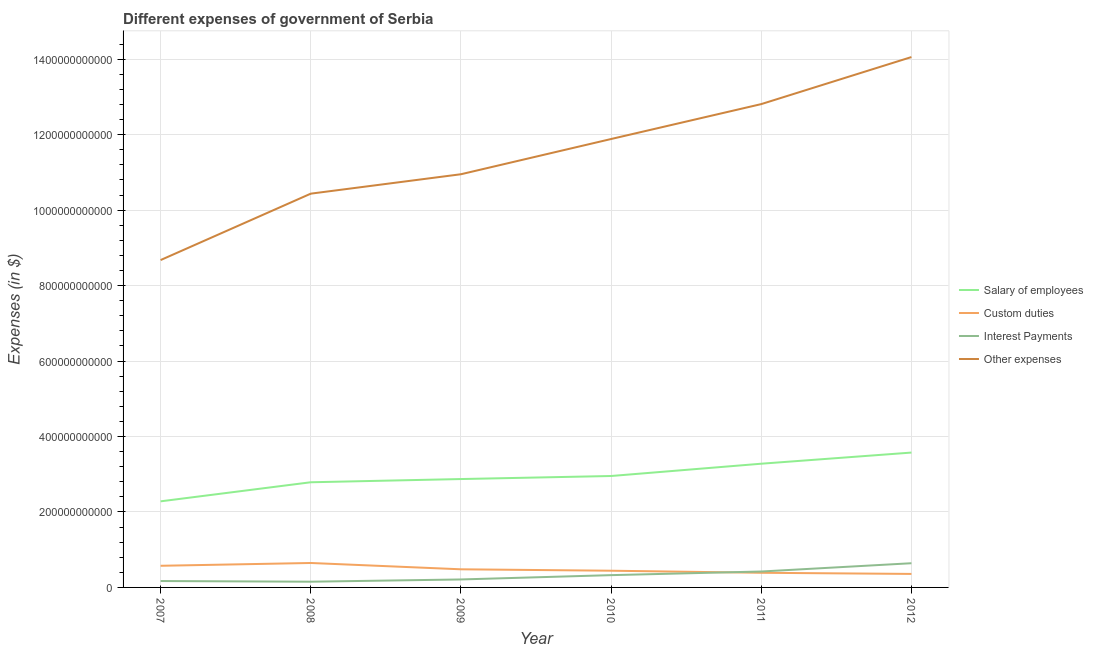What is the amount spent on other expenses in 2010?
Your answer should be compact. 1.19e+12. Across all years, what is the maximum amount spent on interest payments?
Give a very brief answer. 6.41e+1. Across all years, what is the minimum amount spent on interest payments?
Your response must be concise. 1.52e+1. In which year was the amount spent on interest payments maximum?
Your response must be concise. 2012. What is the total amount spent on salary of employees in the graph?
Make the answer very short. 1.77e+12. What is the difference between the amount spent on custom duties in 2008 and that in 2010?
Ensure brevity in your answer.  2.05e+1. What is the difference between the amount spent on interest payments in 2007 and the amount spent on custom duties in 2010?
Provide a succinct answer. -2.73e+1. What is the average amount spent on interest payments per year?
Your response must be concise. 3.20e+1. In the year 2012, what is the difference between the amount spent on custom duties and amount spent on salary of employees?
Your response must be concise. -3.22e+11. What is the ratio of the amount spent on other expenses in 2011 to that in 2012?
Offer a terse response. 0.91. Is the difference between the amount spent on salary of employees in 2007 and 2008 greater than the difference between the amount spent on custom duties in 2007 and 2008?
Your answer should be very brief. No. What is the difference between the highest and the second highest amount spent on custom duties?
Your response must be concise. 7.40e+09. What is the difference between the highest and the lowest amount spent on interest payments?
Your response must be concise. 4.89e+1. In how many years, is the amount spent on custom duties greater than the average amount spent on custom duties taken over all years?
Provide a short and direct response. 2. Is it the case that in every year, the sum of the amount spent on salary of employees and amount spent on custom duties is greater than the sum of amount spent on interest payments and amount spent on other expenses?
Keep it short and to the point. Yes. Is it the case that in every year, the sum of the amount spent on salary of employees and amount spent on custom duties is greater than the amount spent on interest payments?
Provide a succinct answer. Yes. Is the amount spent on interest payments strictly greater than the amount spent on other expenses over the years?
Make the answer very short. No. How many years are there in the graph?
Your answer should be very brief. 6. What is the difference between two consecutive major ticks on the Y-axis?
Ensure brevity in your answer.  2.00e+11. Does the graph contain any zero values?
Provide a short and direct response. No. Where does the legend appear in the graph?
Offer a terse response. Center right. How are the legend labels stacked?
Make the answer very short. Vertical. What is the title of the graph?
Provide a succinct answer. Different expenses of government of Serbia. Does "Taxes on goods and services" appear as one of the legend labels in the graph?
Keep it short and to the point. No. What is the label or title of the X-axis?
Give a very brief answer. Year. What is the label or title of the Y-axis?
Offer a terse response. Expenses (in $). What is the Expenses (in $) of Salary of employees in 2007?
Your answer should be very brief. 2.28e+11. What is the Expenses (in $) in Custom duties in 2007?
Your answer should be very brief. 5.74e+1. What is the Expenses (in $) of Interest Payments in 2007?
Provide a succinct answer. 1.70e+1. What is the Expenses (in $) in Other expenses in 2007?
Give a very brief answer. 8.68e+11. What is the Expenses (in $) in Salary of employees in 2008?
Keep it short and to the point. 2.79e+11. What is the Expenses (in $) in Custom duties in 2008?
Offer a terse response. 6.48e+1. What is the Expenses (in $) in Interest Payments in 2008?
Give a very brief answer. 1.52e+1. What is the Expenses (in $) of Other expenses in 2008?
Provide a short and direct response. 1.04e+12. What is the Expenses (in $) in Salary of employees in 2009?
Offer a terse response. 2.87e+11. What is the Expenses (in $) of Custom duties in 2009?
Your response must be concise. 4.80e+1. What is the Expenses (in $) of Interest Payments in 2009?
Keep it short and to the point. 2.11e+1. What is the Expenses (in $) of Other expenses in 2009?
Your response must be concise. 1.10e+12. What is the Expenses (in $) of Salary of employees in 2010?
Your answer should be compact. 2.95e+11. What is the Expenses (in $) of Custom duties in 2010?
Your answer should be very brief. 4.43e+1. What is the Expenses (in $) in Interest Payments in 2010?
Give a very brief answer. 3.26e+1. What is the Expenses (in $) of Other expenses in 2010?
Provide a short and direct response. 1.19e+12. What is the Expenses (in $) of Salary of employees in 2011?
Provide a succinct answer. 3.28e+11. What is the Expenses (in $) of Custom duties in 2011?
Provide a short and direct response. 3.88e+1. What is the Expenses (in $) of Interest Payments in 2011?
Offer a very short reply. 4.22e+1. What is the Expenses (in $) in Other expenses in 2011?
Offer a very short reply. 1.28e+12. What is the Expenses (in $) of Salary of employees in 2012?
Your response must be concise. 3.57e+11. What is the Expenses (in $) of Custom duties in 2012?
Your answer should be very brief. 3.58e+1. What is the Expenses (in $) of Interest Payments in 2012?
Give a very brief answer. 6.41e+1. What is the Expenses (in $) of Other expenses in 2012?
Your answer should be very brief. 1.41e+12. Across all years, what is the maximum Expenses (in $) in Salary of employees?
Provide a succinct answer. 3.57e+11. Across all years, what is the maximum Expenses (in $) in Custom duties?
Your answer should be very brief. 6.48e+1. Across all years, what is the maximum Expenses (in $) in Interest Payments?
Ensure brevity in your answer.  6.41e+1. Across all years, what is the maximum Expenses (in $) in Other expenses?
Make the answer very short. 1.41e+12. Across all years, what is the minimum Expenses (in $) in Salary of employees?
Offer a terse response. 2.28e+11. Across all years, what is the minimum Expenses (in $) in Custom duties?
Offer a very short reply. 3.58e+1. Across all years, what is the minimum Expenses (in $) in Interest Payments?
Your response must be concise. 1.52e+1. Across all years, what is the minimum Expenses (in $) in Other expenses?
Offer a terse response. 8.68e+11. What is the total Expenses (in $) of Salary of employees in the graph?
Provide a short and direct response. 1.77e+12. What is the total Expenses (in $) of Custom duties in the graph?
Keep it short and to the point. 2.89e+11. What is the total Expenses (in $) of Interest Payments in the graph?
Offer a very short reply. 1.92e+11. What is the total Expenses (in $) in Other expenses in the graph?
Give a very brief answer. 6.88e+12. What is the difference between the Expenses (in $) of Salary of employees in 2007 and that in 2008?
Offer a very short reply. -5.06e+1. What is the difference between the Expenses (in $) of Custom duties in 2007 and that in 2008?
Give a very brief answer. -7.40e+09. What is the difference between the Expenses (in $) in Interest Payments in 2007 and that in 2008?
Give a very brief answer. 1.78e+09. What is the difference between the Expenses (in $) in Other expenses in 2007 and that in 2008?
Your response must be concise. -1.76e+11. What is the difference between the Expenses (in $) in Salary of employees in 2007 and that in 2009?
Your response must be concise. -5.91e+1. What is the difference between the Expenses (in $) of Custom duties in 2007 and that in 2009?
Provide a succinct answer. 9.34e+09. What is the difference between the Expenses (in $) in Interest Payments in 2007 and that in 2009?
Provide a succinct answer. -4.17e+09. What is the difference between the Expenses (in $) in Other expenses in 2007 and that in 2009?
Offer a terse response. -2.27e+11. What is the difference between the Expenses (in $) of Salary of employees in 2007 and that in 2010?
Give a very brief answer. -6.72e+1. What is the difference between the Expenses (in $) in Custom duties in 2007 and that in 2010?
Make the answer very short. 1.31e+1. What is the difference between the Expenses (in $) in Interest Payments in 2007 and that in 2010?
Offer a very short reply. -1.56e+1. What is the difference between the Expenses (in $) in Other expenses in 2007 and that in 2010?
Ensure brevity in your answer.  -3.21e+11. What is the difference between the Expenses (in $) in Salary of employees in 2007 and that in 2011?
Your answer should be very brief. -9.97e+1. What is the difference between the Expenses (in $) of Custom duties in 2007 and that in 2011?
Provide a succinct answer. 1.86e+1. What is the difference between the Expenses (in $) of Interest Payments in 2007 and that in 2011?
Provide a succinct answer. -2.52e+1. What is the difference between the Expenses (in $) in Other expenses in 2007 and that in 2011?
Offer a terse response. -4.13e+11. What is the difference between the Expenses (in $) of Salary of employees in 2007 and that in 2012?
Ensure brevity in your answer.  -1.29e+11. What is the difference between the Expenses (in $) of Custom duties in 2007 and that in 2012?
Give a very brief answer. 2.16e+1. What is the difference between the Expenses (in $) of Interest Payments in 2007 and that in 2012?
Your answer should be very brief. -4.72e+1. What is the difference between the Expenses (in $) in Other expenses in 2007 and that in 2012?
Offer a very short reply. -5.38e+11. What is the difference between the Expenses (in $) of Salary of employees in 2008 and that in 2009?
Keep it short and to the point. -8.54e+09. What is the difference between the Expenses (in $) of Custom duties in 2008 and that in 2009?
Provide a short and direct response. 1.67e+1. What is the difference between the Expenses (in $) in Interest Payments in 2008 and that in 2009?
Offer a terse response. -5.95e+09. What is the difference between the Expenses (in $) in Other expenses in 2008 and that in 2009?
Your response must be concise. -5.15e+1. What is the difference between the Expenses (in $) in Salary of employees in 2008 and that in 2010?
Provide a short and direct response. -1.66e+1. What is the difference between the Expenses (in $) in Custom duties in 2008 and that in 2010?
Make the answer very short. 2.05e+1. What is the difference between the Expenses (in $) of Interest Payments in 2008 and that in 2010?
Offer a very short reply. -1.74e+1. What is the difference between the Expenses (in $) in Other expenses in 2008 and that in 2010?
Offer a very short reply. -1.45e+11. What is the difference between the Expenses (in $) in Salary of employees in 2008 and that in 2011?
Offer a very short reply. -4.92e+1. What is the difference between the Expenses (in $) in Custom duties in 2008 and that in 2011?
Offer a very short reply. 2.60e+1. What is the difference between the Expenses (in $) in Interest Payments in 2008 and that in 2011?
Provide a succinct answer. -2.70e+1. What is the difference between the Expenses (in $) of Other expenses in 2008 and that in 2011?
Provide a short and direct response. -2.37e+11. What is the difference between the Expenses (in $) in Salary of employees in 2008 and that in 2012?
Keep it short and to the point. -7.87e+1. What is the difference between the Expenses (in $) in Custom duties in 2008 and that in 2012?
Your answer should be very brief. 2.90e+1. What is the difference between the Expenses (in $) of Interest Payments in 2008 and that in 2012?
Keep it short and to the point. -4.89e+1. What is the difference between the Expenses (in $) of Other expenses in 2008 and that in 2012?
Your answer should be compact. -3.62e+11. What is the difference between the Expenses (in $) of Salary of employees in 2009 and that in 2010?
Ensure brevity in your answer.  -8.06e+09. What is the difference between the Expenses (in $) in Custom duties in 2009 and that in 2010?
Make the answer very short. 3.75e+09. What is the difference between the Expenses (in $) of Interest Payments in 2009 and that in 2010?
Make the answer very short. -1.14e+1. What is the difference between the Expenses (in $) of Other expenses in 2009 and that in 2010?
Ensure brevity in your answer.  -9.34e+1. What is the difference between the Expenses (in $) of Salary of employees in 2009 and that in 2011?
Give a very brief answer. -4.06e+1. What is the difference between the Expenses (in $) of Custom duties in 2009 and that in 2011?
Your answer should be very brief. 9.24e+09. What is the difference between the Expenses (in $) in Interest Payments in 2009 and that in 2011?
Make the answer very short. -2.11e+1. What is the difference between the Expenses (in $) in Other expenses in 2009 and that in 2011?
Make the answer very short. -1.86e+11. What is the difference between the Expenses (in $) in Salary of employees in 2009 and that in 2012?
Offer a very short reply. -7.02e+1. What is the difference between the Expenses (in $) in Custom duties in 2009 and that in 2012?
Your answer should be very brief. 1.23e+1. What is the difference between the Expenses (in $) of Interest Payments in 2009 and that in 2012?
Offer a very short reply. -4.30e+1. What is the difference between the Expenses (in $) in Other expenses in 2009 and that in 2012?
Make the answer very short. -3.11e+11. What is the difference between the Expenses (in $) of Salary of employees in 2010 and that in 2011?
Your response must be concise. -3.26e+1. What is the difference between the Expenses (in $) of Custom duties in 2010 and that in 2011?
Your answer should be very brief. 5.48e+09. What is the difference between the Expenses (in $) in Interest Payments in 2010 and that in 2011?
Your answer should be very brief. -9.63e+09. What is the difference between the Expenses (in $) in Other expenses in 2010 and that in 2011?
Your answer should be very brief. -9.25e+1. What is the difference between the Expenses (in $) in Salary of employees in 2010 and that in 2012?
Make the answer very short. -6.21e+1. What is the difference between the Expenses (in $) in Custom duties in 2010 and that in 2012?
Ensure brevity in your answer.  8.50e+09. What is the difference between the Expenses (in $) of Interest Payments in 2010 and that in 2012?
Your answer should be very brief. -3.16e+1. What is the difference between the Expenses (in $) of Other expenses in 2010 and that in 2012?
Ensure brevity in your answer.  -2.17e+11. What is the difference between the Expenses (in $) of Salary of employees in 2011 and that in 2012?
Your response must be concise. -2.95e+1. What is the difference between the Expenses (in $) of Custom duties in 2011 and that in 2012?
Offer a very short reply. 3.02e+09. What is the difference between the Expenses (in $) in Interest Payments in 2011 and that in 2012?
Make the answer very short. -2.19e+1. What is the difference between the Expenses (in $) of Other expenses in 2011 and that in 2012?
Provide a short and direct response. -1.25e+11. What is the difference between the Expenses (in $) of Salary of employees in 2007 and the Expenses (in $) of Custom duties in 2008?
Make the answer very short. 1.63e+11. What is the difference between the Expenses (in $) of Salary of employees in 2007 and the Expenses (in $) of Interest Payments in 2008?
Offer a very short reply. 2.13e+11. What is the difference between the Expenses (in $) in Salary of employees in 2007 and the Expenses (in $) in Other expenses in 2008?
Your answer should be compact. -8.15e+11. What is the difference between the Expenses (in $) in Custom duties in 2007 and the Expenses (in $) in Interest Payments in 2008?
Provide a succinct answer. 4.22e+1. What is the difference between the Expenses (in $) of Custom duties in 2007 and the Expenses (in $) of Other expenses in 2008?
Ensure brevity in your answer.  -9.86e+11. What is the difference between the Expenses (in $) in Interest Payments in 2007 and the Expenses (in $) in Other expenses in 2008?
Provide a short and direct response. -1.03e+12. What is the difference between the Expenses (in $) in Salary of employees in 2007 and the Expenses (in $) in Custom duties in 2009?
Your response must be concise. 1.80e+11. What is the difference between the Expenses (in $) of Salary of employees in 2007 and the Expenses (in $) of Interest Payments in 2009?
Your response must be concise. 2.07e+11. What is the difference between the Expenses (in $) in Salary of employees in 2007 and the Expenses (in $) in Other expenses in 2009?
Give a very brief answer. -8.67e+11. What is the difference between the Expenses (in $) of Custom duties in 2007 and the Expenses (in $) of Interest Payments in 2009?
Keep it short and to the point. 3.62e+1. What is the difference between the Expenses (in $) of Custom duties in 2007 and the Expenses (in $) of Other expenses in 2009?
Ensure brevity in your answer.  -1.04e+12. What is the difference between the Expenses (in $) in Interest Payments in 2007 and the Expenses (in $) in Other expenses in 2009?
Make the answer very short. -1.08e+12. What is the difference between the Expenses (in $) in Salary of employees in 2007 and the Expenses (in $) in Custom duties in 2010?
Your answer should be very brief. 1.84e+11. What is the difference between the Expenses (in $) in Salary of employees in 2007 and the Expenses (in $) in Interest Payments in 2010?
Provide a succinct answer. 1.96e+11. What is the difference between the Expenses (in $) of Salary of employees in 2007 and the Expenses (in $) of Other expenses in 2010?
Give a very brief answer. -9.60e+11. What is the difference between the Expenses (in $) of Custom duties in 2007 and the Expenses (in $) of Interest Payments in 2010?
Provide a short and direct response. 2.48e+1. What is the difference between the Expenses (in $) of Custom duties in 2007 and the Expenses (in $) of Other expenses in 2010?
Your answer should be very brief. -1.13e+12. What is the difference between the Expenses (in $) in Interest Payments in 2007 and the Expenses (in $) in Other expenses in 2010?
Ensure brevity in your answer.  -1.17e+12. What is the difference between the Expenses (in $) in Salary of employees in 2007 and the Expenses (in $) in Custom duties in 2011?
Offer a terse response. 1.89e+11. What is the difference between the Expenses (in $) of Salary of employees in 2007 and the Expenses (in $) of Interest Payments in 2011?
Your answer should be very brief. 1.86e+11. What is the difference between the Expenses (in $) in Salary of employees in 2007 and the Expenses (in $) in Other expenses in 2011?
Offer a very short reply. -1.05e+12. What is the difference between the Expenses (in $) in Custom duties in 2007 and the Expenses (in $) in Interest Payments in 2011?
Ensure brevity in your answer.  1.52e+1. What is the difference between the Expenses (in $) of Custom duties in 2007 and the Expenses (in $) of Other expenses in 2011?
Offer a terse response. -1.22e+12. What is the difference between the Expenses (in $) of Interest Payments in 2007 and the Expenses (in $) of Other expenses in 2011?
Make the answer very short. -1.26e+12. What is the difference between the Expenses (in $) of Salary of employees in 2007 and the Expenses (in $) of Custom duties in 2012?
Your response must be concise. 1.92e+11. What is the difference between the Expenses (in $) in Salary of employees in 2007 and the Expenses (in $) in Interest Payments in 2012?
Provide a short and direct response. 1.64e+11. What is the difference between the Expenses (in $) of Salary of employees in 2007 and the Expenses (in $) of Other expenses in 2012?
Offer a terse response. -1.18e+12. What is the difference between the Expenses (in $) in Custom duties in 2007 and the Expenses (in $) in Interest Payments in 2012?
Keep it short and to the point. -6.75e+09. What is the difference between the Expenses (in $) of Custom duties in 2007 and the Expenses (in $) of Other expenses in 2012?
Your answer should be compact. -1.35e+12. What is the difference between the Expenses (in $) of Interest Payments in 2007 and the Expenses (in $) of Other expenses in 2012?
Your answer should be very brief. -1.39e+12. What is the difference between the Expenses (in $) of Salary of employees in 2008 and the Expenses (in $) of Custom duties in 2009?
Ensure brevity in your answer.  2.31e+11. What is the difference between the Expenses (in $) of Salary of employees in 2008 and the Expenses (in $) of Interest Payments in 2009?
Your answer should be compact. 2.58e+11. What is the difference between the Expenses (in $) of Salary of employees in 2008 and the Expenses (in $) of Other expenses in 2009?
Give a very brief answer. -8.16e+11. What is the difference between the Expenses (in $) of Custom duties in 2008 and the Expenses (in $) of Interest Payments in 2009?
Offer a terse response. 4.37e+1. What is the difference between the Expenses (in $) in Custom duties in 2008 and the Expenses (in $) in Other expenses in 2009?
Your answer should be very brief. -1.03e+12. What is the difference between the Expenses (in $) in Interest Payments in 2008 and the Expenses (in $) in Other expenses in 2009?
Make the answer very short. -1.08e+12. What is the difference between the Expenses (in $) of Salary of employees in 2008 and the Expenses (in $) of Custom duties in 2010?
Keep it short and to the point. 2.34e+11. What is the difference between the Expenses (in $) of Salary of employees in 2008 and the Expenses (in $) of Interest Payments in 2010?
Provide a short and direct response. 2.46e+11. What is the difference between the Expenses (in $) of Salary of employees in 2008 and the Expenses (in $) of Other expenses in 2010?
Provide a succinct answer. -9.10e+11. What is the difference between the Expenses (in $) in Custom duties in 2008 and the Expenses (in $) in Interest Payments in 2010?
Provide a succinct answer. 3.22e+1. What is the difference between the Expenses (in $) in Custom duties in 2008 and the Expenses (in $) in Other expenses in 2010?
Your answer should be very brief. -1.12e+12. What is the difference between the Expenses (in $) of Interest Payments in 2008 and the Expenses (in $) of Other expenses in 2010?
Offer a terse response. -1.17e+12. What is the difference between the Expenses (in $) in Salary of employees in 2008 and the Expenses (in $) in Custom duties in 2011?
Give a very brief answer. 2.40e+11. What is the difference between the Expenses (in $) in Salary of employees in 2008 and the Expenses (in $) in Interest Payments in 2011?
Ensure brevity in your answer.  2.37e+11. What is the difference between the Expenses (in $) of Salary of employees in 2008 and the Expenses (in $) of Other expenses in 2011?
Your answer should be compact. -1.00e+12. What is the difference between the Expenses (in $) of Custom duties in 2008 and the Expenses (in $) of Interest Payments in 2011?
Offer a terse response. 2.26e+1. What is the difference between the Expenses (in $) of Custom duties in 2008 and the Expenses (in $) of Other expenses in 2011?
Ensure brevity in your answer.  -1.22e+12. What is the difference between the Expenses (in $) of Interest Payments in 2008 and the Expenses (in $) of Other expenses in 2011?
Provide a short and direct response. -1.27e+12. What is the difference between the Expenses (in $) of Salary of employees in 2008 and the Expenses (in $) of Custom duties in 2012?
Make the answer very short. 2.43e+11. What is the difference between the Expenses (in $) in Salary of employees in 2008 and the Expenses (in $) in Interest Payments in 2012?
Your answer should be very brief. 2.15e+11. What is the difference between the Expenses (in $) of Salary of employees in 2008 and the Expenses (in $) of Other expenses in 2012?
Give a very brief answer. -1.13e+12. What is the difference between the Expenses (in $) in Custom duties in 2008 and the Expenses (in $) in Interest Payments in 2012?
Give a very brief answer. 6.49e+08. What is the difference between the Expenses (in $) in Custom duties in 2008 and the Expenses (in $) in Other expenses in 2012?
Offer a terse response. -1.34e+12. What is the difference between the Expenses (in $) of Interest Payments in 2008 and the Expenses (in $) of Other expenses in 2012?
Give a very brief answer. -1.39e+12. What is the difference between the Expenses (in $) in Salary of employees in 2009 and the Expenses (in $) in Custom duties in 2010?
Your answer should be compact. 2.43e+11. What is the difference between the Expenses (in $) of Salary of employees in 2009 and the Expenses (in $) of Interest Payments in 2010?
Ensure brevity in your answer.  2.55e+11. What is the difference between the Expenses (in $) in Salary of employees in 2009 and the Expenses (in $) in Other expenses in 2010?
Give a very brief answer. -9.01e+11. What is the difference between the Expenses (in $) of Custom duties in 2009 and the Expenses (in $) of Interest Payments in 2010?
Your answer should be very brief. 1.55e+1. What is the difference between the Expenses (in $) of Custom duties in 2009 and the Expenses (in $) of Other expenses in 2010?
Provide a short and direct response. -1.14e+12. What is the difference between the Expenses (in $) of Interest Payments in 2009 and the Expenses (in $) of Other expenses in 2010?
Make the answer very short. -1.17e+12. What is the difference between the Expenses (in $) of Salary of employees in 2009 and the Expenses (in $) of Custom duties in 2011?
Your response must be concise. 2.48e+11. What is the difference between the Expenses (in $) of Salary of employees in 2009 and the Expenses (in $) of Interest Payments in 2011?
Give a very brief answer. 2.45e+11. What is the difference between the Expenses (in $) in Salary of employees in 2009 and the Expenses (in $) in Other expenses in 2011?
Make the answer very short. -9.94e+11. What is the difference between the Expenses (in $) of Custom duties in 2009 and the Expenses (in $) of Interest Payments in 2011?
Make the answer very short. 5.85e+09. What is the difference between the Expenses (in $) of Custom duties in 2009 and the Expenses (in $) of Other expenses in 2011?
Give a very brief answer. -1.23e+12. What is the difference between the Expenses (in $) in Interest Payments in 2009 and the Expenses (in $) in Other expenses in 2011?
Provide a short and direct response. -1.26e+12. What is the difference between the Expenses (in $) in Salary of employees in 2009 and the Expenses (in $) in Custom duties in 2012?
Make the answer very short. 2.51e+11. What is the difference between the Expenses (in $) of Salary of employees in 2009 and the Expenses (in $) of Interest Payments in 2012?
Offer a very short reply. 2.23e+11. What is the difference between the Expenses (in $) in Salary of employees in 2009 and the Expenses (in $) in Other expenses in 2012?
Provide a succinct answer. -1.12e+12. What is the difference between the Expenses (in $) in Custom duties in 2009 and the Expenses (in $) in Interest Payments in 2012?
Offer a very short reply. -1.61e+1. What is the difference between the Expenses (in $) of Custom duties in 2009 and the Expenses (in $) of Other expenses in 2012?
Provide a short and direct response. -1.36e+12. What is the difference between the Expenses (in $) of Interest Payments in 2009 and the Expenses (in $) of Other expenses in 2012?
Ensure brevity in your answer.  -1.38e+12. What is the difference between the Expenses (in $) in Salary of employees in 2010 and the Expenses (in $) in Custom duties in 2011?
Your answer should be very brief. 2.57e+11. What is the difference between the Expenses (in $) in Salary of employees in 2010 and the Expenses (in $) in Interest Payments in 2011?
Keep it short and to the point. 2.53e+11. What is the difference between the Expenses (in $) in Salary of employees in 2010 and the Expenses (in $) in Other expenses in 2011?
Ensure brevity in your answer.  -9.86e+11. What is the difference between the Expenses (in $) in Custom duties in 2010 and the Expenses (in $) in Interest Payments in 2011?
Give a very brief answer. 2.09e+09. What is the difference between the Expenses (in $) of Custom duties in 2010 and the Expenses (in $) of Other expenses in 2011?
Offer a terse response. -1.24e+12. What is the difference between the Expenses (in $) of Interest Payments in 2010 and the Expenses (in $) of Other expenses in 2011?
Offer a very short reply. -1.25e+12. What is the difference between the Expenses (in $) in Salary of employees in 2010 and the Expenses (in $) in Custom duties in 2012?
Keep it short and to the point. 2.60e+11. What is the difference between the Expenses (in $) in Salary of employees in 2010 and the Expenses (in $) in Interest Payments in 2012?
Provide a short and direct response. 2.31e+11. What is the difference between the Expenses (in $) of Salary of employees in 2010 and the Expenses (in $) of Other expenses in 2012?
Your answer should be compact. -1.11e+12. What is the difference between the Expenses (in $) in Custom duties in 2010 and the Expenses (in $) in Interest Payments in 2012?
Your response must be concise. -1.98e+1. What is the difference between the Expenses (in $) in Custom duties in 2010 and the Expenses (in $) in Other expenses in 2012?
Offer a terse response. -1.36e+12. What is the difference between the Expenses (in $) of Interest Payments in 2010 and the Expenses (in $) of Other expenses in 2012?
Ensure brevity in your answer.  -1.37e+12. What is the difference between the Expenses (in $) in Salary of employees in 2011 and the Expenses (in $) in Custom duties in 2012?
Give a very brief answer. 2.92e+11. What is the difference between the Expenses (in $) in Salary of employees in 2011 and the Expenses (in $) in Interest Payments in 2012?
Keep it short and to the point. 2.64e+11. What is the difference between the Expenses (in $) of Salary of employees in 2011 and the Expenses (in $) of Other expenses in 2012?
Offer a very short reply. -1.08e+12. What is the difference between the Expenses (in $) in Custom duties in 2011 and the Expenses (in $) in Interest Payments in 2012?
Ensure brevity in your answer.  -2.53e+1. What is the difference between the Expenses (in $) in Custom duties in 2011 and the Expenses (in $) in Other expenses in 2012?
Provide a succinct answer. -1.37e+12. What is the difference between the Expenses (in $) of Interest Payments in 2011 and the Expenses (in $) of Other expenses in 2012?
Your answer should be very brief. -1.36e+12. What is the average Expenses (in $) in Salary of employees per year?
Keep it short and to the point. 2.96e+11. What is the average Expenses (in $) of Custom duties per year?
Keep it short and to the point. 4.82e+1. What is the average Expenses (in $) in Interest Payments per year?
Your answer should be very brief. 3.20e+1. What is the average Expenses (in $) of Other expenses per year?
Keep it short and to the point. 1.15e+12. In the year 2007, what is the difference between the Expenses (in $) of Salary of employees and Expenses (in $) of Custom duties?
Offer a terse response. 1.71e+11. In the year 2007, what is the difference between the Expenses (in $) in Salary of employees and Expenses (in $) in Interest Payments?
Make the answer very short. 2.11e+11. In the year 2007, what is the difference between the Expenses (in $) of Salary of employees and Expenses (in $) of Other expenses?
Ensure brevity in your answer.  -6.39e+11. In the year 2007, what is the difference between the Expenses (in $) of Custom duties and Expenses (in $) of Interest Payments?
Offer a very short reply. 4.04e+1. In the year 2007, what is the difference between the Expenses (in $) of Custom duties and Expenses (in $) of Other expenses?
Your answer should be compact. -8.10e+11. In the year 2007, what is the difference between the Expenses (in $) of Interest Payments and Expenses (in $) of Other expenses?
Make the answer very short. -8.51e+11. In the year 2008, what is the difference between the Expenses (in $) of Salary of employees and Expenses (in $) of Custom duties?
Offer a very short reply. 2.14e+11. In the year 2008, what is the difference between the Expenses (in $) of Salary of employees and Expenses (in $) of Interest Payments?
Keep it short and to the point. 2.64e+11. In the year 2008, what is the difference between the Expenses (in $) of Salary of employees and Expenses (in $) of Other expenses?
Keep it short and to the point. -7.65e+11. In the year 2008, what is the difference between the Expenses (in $) in Custom duties and Expenses (in $) in Interest Payments?
Your response must be concise. 4.96e+1. In the year 2008, what is the difference between the Expenses (in $) in Custom duties and Expenses (in $) in Other expenses?
Your answer should be compact. -9.79e+11. In the year 2008, what is the difference between the Expenses (in $) in Interest Payments and Expenses (in $) in Other expenses?
Offer a very short reply. -1.03e+12. In the year 2009, what is the difference between the Expenses (in $) of Salary of employees and Expenses (in $) of Custom duties?
Offer a terse response. 2.39e+11. In the year 2009, what is the difference between the Expenses (in $) in Salary of employees and Expenses (in $) in Interest Payments?
Provide a succinct answer. 2.66e+11. In the year 2009, what is the difference between the Expenses (in $) of Salary of employees and Expenses (in $) of Other expenses?
Keep it short and to the point. -8.08e+11. In the year 2009, what is the difference between the Expenses (in $) of Custom duties and Expenses (in $) of Interest Payments?
Give a very brief answer. 2.69e+1. In the year 2009, what is the difference between the Expenses (in $) of Custom duties and Expenses (in $) of Other expenses?
Keep it short and to the point. -1.05e+12. In the year 2009, what is the difference between the Expenses (in $) in Interest Payments and Expenses (in $) in Other expenses?
Give a very brief answer. -1.07e+12. In the year 2010, what is the difference between the Expenses (in $) in Salary of employees and Expenses (in $) in Custom duties?
Keep it short and to the point. 2.51e+11. In the year 2010, what is the difference between the Expenses (in $) in Salary of employees and Expenses (in $) in Interest Payments?
Make the answer very short. 2.63e+11. In the year 2010, what is the difference between the Expenses (in $) of Salary of employees and Expenses (in $) of Other expenses?
Make the answer very short. -8.93e+11. In the year 2010, what is the difference between the Expenses (in $) in Custom duties and Expenses (in $) in Interest Payments?
Give a very brief answer. 1.17e+1. In the year 2010, what is the difference between the Expenses (in $) in Custom duties and Expenses (in $) in Other expenses?
Make the answer very short. -1.14e+12. In the year 2010, what is the difference between the Expenses (in $) of Interest Payments and Expenses (in $) of Other expenses?
Offer a very short reply. -1.16e+12. In the year 2011, what is the difference between the Expenses (in $) of Salary of employees and Expenses (in $) of Custom duties?
Offer a very short reply. 2.89e+11. In the year 2011, what is the difference between the Expenses (in $) of Salary of employees and Expenses (in $) of Interest Payments?
Provide a short and direct response. 2.86e+11. In the year 2011, what is the difference between the Expenses (in $) of Salary of employees and Expenses (in $) of Other expenses?
Provide a succinct answer. -9.53e+11. In the year 2011, what is the difference between the Expenses (in $) in Custom duties and Expenses (in $) in Interest Payments?
Provide a short and direct response. -3.39e+09. In the year 2011, what is the difference between the Expenses (in $) in Custom duties and Expenses (in $) in Other expenses?
Your response must be concise. -1.24e+12. In the year 2011, what is the difference between the Expenses (in $) in Interest Payments and Expenses (in $) in Other expenses?
Your response must be concise. -1.24e+12. In the year 2012, what is the difference between the Expenses (in $) of Salary of employees and Expenses (in $) of Custom duties?
Give a very brief answer. 3.22e+11. In the year 2012, what is the difference between the Expenses (in $) of Salary of employees and Expenses (in $) of Interest Payments?
Make the answer very short. 2.93e+11. In the year 2012, what is the difference between the Expenses (in $) of Salary of employees and Expenses (in $) of Other expenses?
Provide a succinct answer. -1.05e+12. In the year 2012, what is the difference between the Expenses (in $) of Custom duties and Expenses (in $) of Interest Payments?
Your answer should be very brief. -2.84e+1. In the year 2012, what is the difference between the Expenses (in $) of Custom duties and Expenses (in $) of Other expenses?
Your response must be concise. -1.37e+12. In the year 2012, what is the difference between the Expenses (in $) in Interest Payments and Expenses (in $) in Other expenses?
Give a very brief answer. -1.34e+12. What is the ratio of the Expenses (in $) in Salary of employees in 2007 to that in 2008?
Offer a very short reply. 0.82. What is the ratio of the Expenses (in $) of Custom duties in 2007 to that in 2008?
Your answer should be very brief. 0.89. What is the ratio of the Expenses (in $) of Interest Payments in 2007 to that in 2008?
Your answer should be compact. 1.12. What is the ratio of the Expenses (in $) of Other expenses in 2007 to that in 2008?
Your answer should be compact. 0.83. What is the ratio of the Expenses (in $) of Salary of employees in 2007 to that in 2009?
Ensure brevity in your answer.  0.79. What is the ratio of the Expenses (in $) in Custom duties in 2007 to that in 2009?
Provide a succinct answer. 1.19. What is the ratio of the Expenses (in $) in Interest Payments in 2007 to that in 2009?
Give a very brief answer. 0.8. What is the ratio of the Expenses (in $) of Other expenses in 2007 to that in 2009?
Offer a very short reply. 0.79. What is the ratio of the Expenses (in $) in Salary of employees in 2007 to that in 2010?
Make the answer very short. 0.77. What is the ratio of the Expenses (in $) of Custom duties in 2007 to that in 2010?
Provide a succinct answer. 1.3. What is the ratio of the Expenses (in $) in Interest Payments in 2007 to that in 2010?
Provide a succinct answer. 0.52. What is the ratio of the Expenses (in $) in Other expenses in 2007 to that in 2010?
Your response must be concise. 0.73. What is the ratio of the Expenses (in $) in Salary of employees in 2007 to that in 2011?
Provide a short and direct response. 0.7. What is the ratio of the Expenses (in $) of Custom duties in 2007 to that in 2011?
Make the answer very short. 1.48. What is the ratio of the Expenses (in $) in Interest Payments in 2007 to that in 2011?
Your answer should be compact. 0.4. What is the ratio of the Expenses (in $) of Other expenses in 2007 to that in 2011?
Your response must be concise. 0.68. What is the ratio of the Expenses (in $) of Salary of employees in 2007 to that in 2012?
Provide a short and direct response. 0.64. What is the ratio of the Expenses (in $) of Custom duties in 2007 to that in 2012?
Keep it short and to the point. 1.6. What is the ratio of the Expenses (in $) of Interest Payments in 2007 to that in 2012?
Provide a succinct answer. 0.26. What is the ratio of the Expenses (in $) in Other expenses in 2007 to that in 2012?
Ensure brevity in your answer.  0.62. What is the ratio of the Expenses (in $) of Salary of employees in 2008 to that in 2009?
Offer a very short reply. 0.97. What is the ratio of the Expenses (in $) in Custom duties in 2008 to that in 2009?
Your answer should be compact. 1.35. What is the ratio of the Expenses (in $) of Interest Payments in 2008 to that in 2009?
Keep it short and to the point. 0.72. What is the ratio of the Expenses (in $) in Other expenses in 2008 to that in 2009?
Ensure brevity in your answer.  0.95. What is the ratio of the Expenses (in $) in Salary of employees in 2008 to that in 2010?
Offer a very short reply. 0.94. What is the ratio of the Expenses (in $) of Custom duties in 2008 to that in 2010?
Ensure brevity in your answer.  1.46. What is the ratio of the Expenses (in $) in Interest Payments in 2008 to that in 2010?
Your answer should be very brief. 0.47. What is the ratio of the Expenses (in $) of Other expenses in 2008 to that in 2010?
Give a very brief answer. 0.88. What is the ratio of the Expenses (in $) of Salary of employees in 2008 to that in 2011?
Ensure brevity in your answer.  0.85. What is the ratio of the Expenses (in $) in Custom duties in 2008 to that in 2011?
Offer a terse response. 1.67. What is the ratio of the Expenses (in $) of Interest Payments in 2008 to that in 2011?
Give a very brief answer. 0.36. What is the ratio of the Expenses (in $) of Other expenses in 2008 to that in 2011?
Keep it short and to the point. 0.81. What is the ratio of the Expenses (in $) of Salary of employees in 2008 to that in 2012?
Give a very brief answer. 0.78. What is the ratio of the Expenses (in $) of Custom duties in 2008 to that in 2012?
Your answer should be compact. 1.81. What is the ratio of the Expenses (in $) of Interest Payments in 2008 to that in 2012?
Provide a short and direct response. 0.24. What is the ratio of the Expenses (in $) of Other expenses in 2008 to that in 2012?
Provide a short and direct response. 0.74. What is the ratio of the Expenses (in $) in Salary of employees in 2009 to that in 2010?
Keep it short and to the point. 0.97. What is the ratio of the Expenses (in $) in Custom duties in 2009 to that in 2010?
Offer a terse response. 1.08. What is the ratio of the Expenses (in $) of Interest Payments in 2009 to that in 2010?
Your answer should be compact. 0.65. What is the ratio of the Expenses (in $) of Other expenses in 2009 to that in 2010?
Ensure brevity in your answer.  0.92. What is the ratio of the Expenses (in $) of Salary of employees in 2009 to that in 2011?
Offer a very short reply. 0.88. What is the ratio of the Expenses (in $) in Custom duties in 2009 to that in 2011?
Provide a short and direct response. 1.24. What is the ratio of the Expenses (in $) of Interest Payments in 2009 to that in 2011?
Give a very brief answer. 0.5. What is the ratio of the Expenses (in $) in Other expenses in 2009 to that in 2011?
Keep it short and to the point. 0.85. What is the ratio of the Expenses (in $) in Salary of employees in 2009 to that in 2012?
Make the answer very short. 0.8. What is the ratio of the Expenses (in $) in Custom duties in 2009 to that in 2012?
Provide a succinct answer. 1.34. What is the ratio of the Expenses (in $) in Interest Payments in 2009 to that in 2012?
Give a very brief answer. 0.33. What is the ratio of the Expenses (in $) in Other expenses in 2009 to that in 2012?
Provide a succinct answer. 0.78. What is the ratio of the Expenses (in $) in Salary of employees in 2010 to that in 2011?
Your answer should be very brief. 0.9. What is the ratio of the Expenses (in $) of Custom duties in 2010 to that in 2011?
Your answer should be very brief. 1.14. What is the ratio of the Expenses (in $) of Interest Payments in 2010 to that in 2011?
Provide a succinct answer. 0.77. What is the ratio of the Expenses (in $) in Other expenses in 2010 to that in 2011?
Offer a terse response. 0.93. What is the ratio of the Expenses (in $) in Salary of employees in 2010 to that in 2012?
Offer a terse response. 0.83. What is the ratio of the Expenses (in $) of Custom duties in 2010 to that in 2012?
Your answer should be compact. 1.24. What is the ratio of the Expenses (in $) in Interest Payments in 2010 to that in 2012?
Keep it short and to the point. 0.51. What is the ratio of the Expenses (in $) of Other expenses in 2010 to that in 2012?
Keep it short and to the point. 0.85. What is the ratio of the Expenses (in $) in Salary of employees in 2011 to that in 2012?
Your response must be concise. 0.92. What is the ratio of the Expenses (in $) in Custom duties in 2011 to that in 2012?
Make the answer very short. 1.08. What is the ratio of the Expenses (in $) of Interest Payments in 2011 to that in 2012?
Your answer should be compact. 0.66. What is the ratio of the Expenses (in $) of Other expenses in 2011 to that in 2012?
Provide a short and direct response. 0.91. What is the difference between the highest and the second highest Expenses (in $) of Salary of employees?
Give a very brief answer. 2.95e+1. What is the difference between the highest and the second highest Expenses (in $) of Custom duties?
Make the answer very short. 7.40e+09. What is the difference between the highest and the second highest Expenses (in $) of Interest Payments?
Offer a very short reply. 2.19e+1. What is the difference between the highest and the second highest Expenses (in $) of Other expenses?
Your answer should be compact. 1.25e+11. What is the difference between the highest and the lowest Expenses (in $) in Salary of employees?
Provide a succinct answer. 1.29e+11. What is the difference between the highest and the lowest Expenses (in $) in Custom duties?
Provide a succinct answer. 2.90e+1. What is the difference between the highest and the lowest Expenses (in $) of Interest Payments?
Keep it short and to the point. 4.89e+1. What is the difference between the highest and the lowest Expenses (in $) of Other expenses?
Offer a terse response. 5.38e+11. 